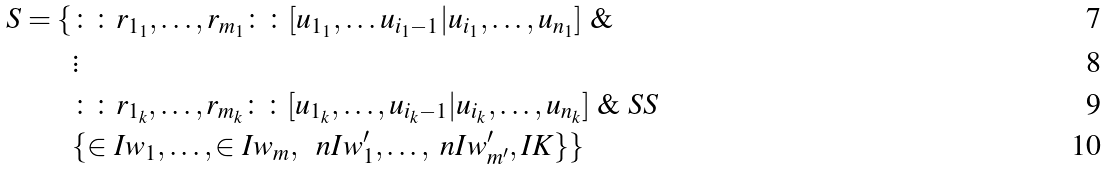<formula> <loc_0><loc_0><loc_500><loc_500>S = \{ & \colon \colon r _ { 1 _ { 1 } } , \dots , r _ { m _ { 1 } } \colon \colon [ u _ { 1 _ { 1 } } , \dots u _ { i _ { 1 } - 1 } | u _ { i _ { 1 } } , \dots , u _ { n _ { 1 } } ] \ \& \\ & \vdots \\ & \colon \colon r _ { 1 _ { k } } , \dots , r _ { m _ { k } } \colon \colon [ u _ { 1 _ { k } } , \dots , u _ { i _ { k } - 1 } | u _ { i _ { k } } , \dots , u _ { n _ { k } } ] \ \& \ S S \ \\ & \{ \in I { w _ { 1 } } , \dots , \in I { w _ { m } } , \ \ n I { w ^ { \prime } _ { 1 } } , \dots , \ n I { w ^ { \prime } _ { m ^ { \prime } } } , I K \} \}</formula> 